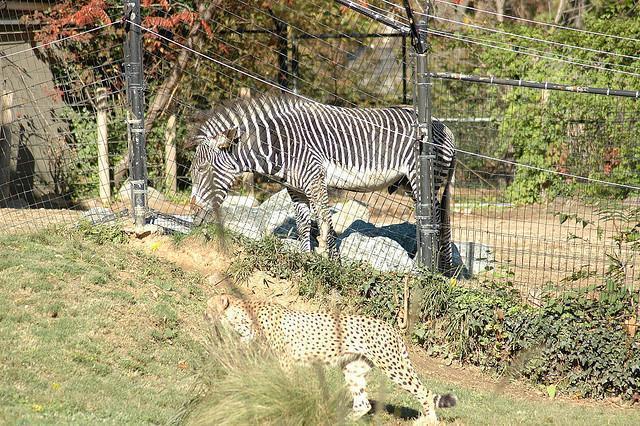How many animals are in the image?
Give a very brief answer. 2. How many zebras are in the picture?
Give a very brief answer. 1. 